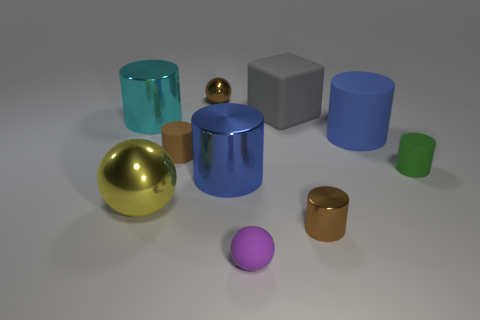Subtract all cyan cylinders. How many cylinders are left? 5 Subtract all large blue metallic cylinders. How many cylinders are left? 5 Subtract all cyan cylinders. Subtract all cyan spheres. How many cylinders are left? 5 Subtract all cylinders. How many objects are left? 4 Add 2 rubber things. How many rubber things are left? 7 Add 4 blue metal cylinders. How many blue metal cylinders exist? 5 Subtract 0 brown blocks. How many objects are left? 10 Subtract all small purple balls. Subtract all small red matte balls. How many objects are left? 9 